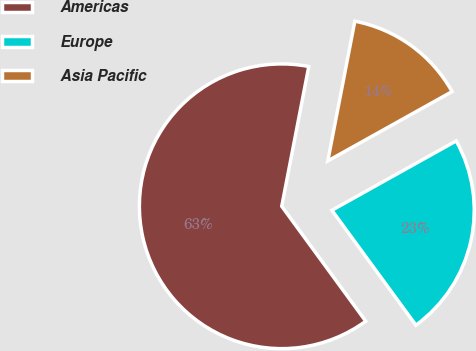Convert chart. <chart><loc_0><loc_0><loc_500><loc_500><pie_chart><fcel>Americas<fcel>Europe<fcel>Asia Pacific<nl><fcel>63.09%<fcel>23.05%<fcel>13.86%<nl></chart> 